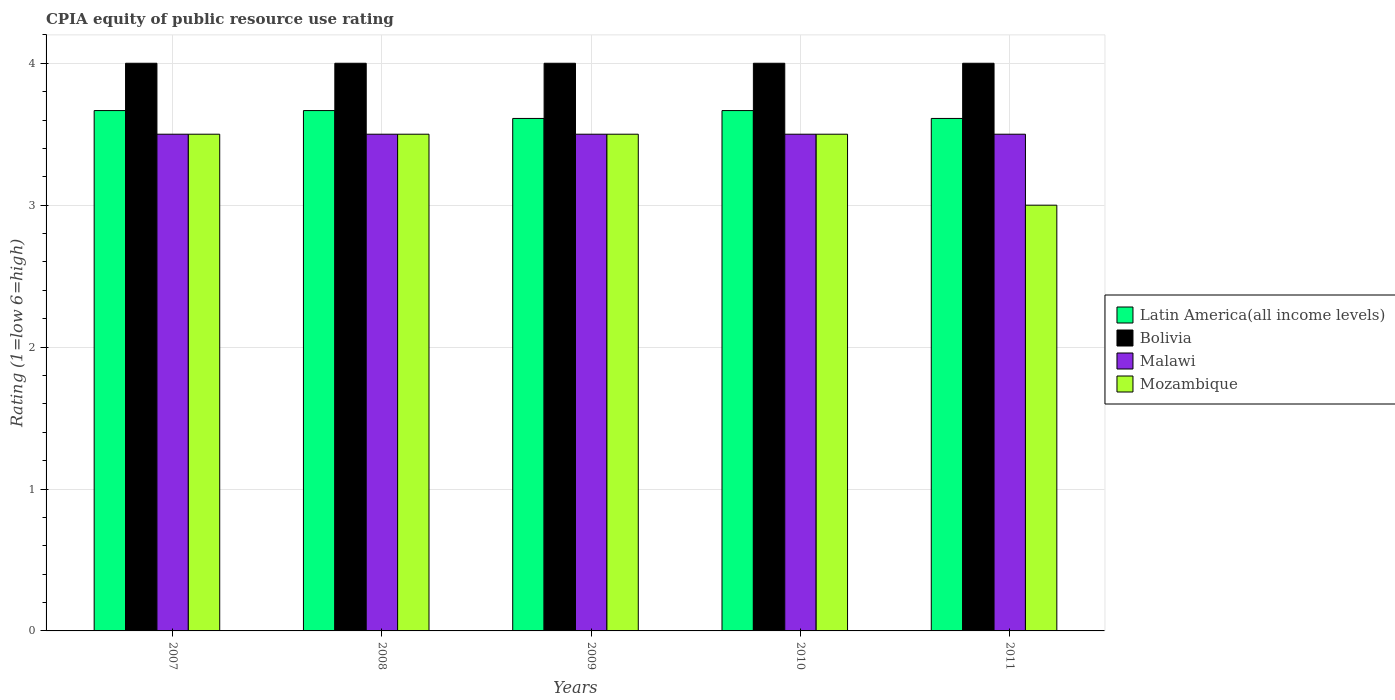How many different coloured bars are there?
Make the answer very short. 4. Are the number of bars on each tick of the X-axis equal?
Make the answer very short. Yes. How many bars are there on the 3rd tick from the right?
Ensure brevity in your answer.  4. What is the label of the 2nd group of bars from the left?
Offer a very short reply. 2008. In how many cases, is the number of bars for a given year not equal to the number of legend labels?
Ensure brevity in your answer.  0. What is the CPIA rating in Bolivia in 2009?
Give a very brief answer. 4. Across all years, what is the maximum CPIA rating in Malawi?
Provide a succinct answer. 3.5. Across all years, what is the minimum CPIA rating in Latin America(all income levels)?
Offer a terse response. 3.61. In which year was the CPIA rating in Mozambique minimum?
Your answer should be compact. 2011. What is the total CPIA rating in Malawi in the graph?
Make the answer very short. 17.5. What is the difference between the CPIA rating in Latin America(all income levels) in 2008 and that in 2011?
Your answer should be compact. 0.06. What is the difference between the CPIA rating in Latin America(all income levels) in 2011 and the CPIA rating in Bolivia in 2010?
Your answer should be very brief. -0.39. What is the average CPIA rating in Latin America(all income levels) per year?
Your answer should be very brief. 3.64. What is the ratio of the CPIA rating in Mozambique in 2009 to that in 2011?
Ensure brevity in your answer.  1.17. Is the CPIA rating in Bolivia in 2007 less than that in 2008?
Provide a short and direct response. No. What is the difference between the highest and the second highest CPIA rating in Bolivia?
Make the answer very short. 0. What is the difference between the highest and the lowest CPIA rating in Latin America(all income levels)?
Your answer should be very brief. 0.06. In how many years, is the CPIA rating in Bolivia greater than the average CPIA rating in Bolivia taken over all years?
Provide a succinct answer. 0. Is it the case that in every year, the sum of the CPIA rating in Malawi and CPIA rating in Bolivia is greater than the sum of CPIA rating in Latin America(all income levels) and CPIA rating in Mozambique?
Give a very brief answer. No. What does the 3rd bar from the left in 2010 represents?
Provide a succinct answer. Malawi. What does the 1st bar from the right in 2011 represents?
Offer a terse response. Mozambique. How many bars are there?
Provide a short and direct response. 20. Are all the bars in the graph horizontal?
Your answer should be very brief. No. Are the values on the major ticks of Y-axis written in scientific E-notation?
Provide a succinct answer. No. Where does the legend appear in the graph?
Ensure brevity in your answer.  Center right. How many legend labels are there?
Make the answer very short. 4. What is the title of the graph?
Your response must be concise. CPIA equity of public resource use rating. What is the Rating (1=low 6=high) of Latin America(all income levels) in 2007?
Offer a terse response. 3.67. What is the Rating (1=low 6=high) of Malawi in 2007?
Offer a terse response. 3.5. What is the Rating (1=low 6=high) of Mozambique in 2007?
Keep it short and to the point. 3.5. What is the Rating (1=low 6=high) in Latin America(all income levels) in 2008?
Make the answer very short. 3.67. What is the Rating (1=low 6=high) in Bolivia in 2008?
Offer a terse response. 4. What is the Rating (1=low 6=high) in Malawi in 2008?
Keep it short and to the point. 3.5. What is the Rating (1=low 6=high) of Mozambique in 2008?
Your answer should be very brief. 3.5. What is the Rating (1=low 6=high) of Latin America(all income levels) in 2009?
Make the answer very short. 3.61. What is the Rating (1=low 6=high) in Bolivia in 2009?
Your answer should be compact. 4. What is the Rating (1=low 6=high) of Mozambique in 2009?
Provide a short and direct response. 3.5. What is the Rating (1=low 6=high) in Latin America(all income levels) in 2010?
Provide a short and direct response. 3.67. What is the Rating (1=low 6=high) in Malawi in 2010?
Ensure brevity in your answer.  3.5. What is the Rating (1=low 6=high) in Mozambique in 2010?
Your answer should be very brief. 3.5. What is the Rating (1=low 6=high) in Latin America(all income levels) in 2011?
Provide a succinct answer. 3.61. Across all years, what is the maximum Rating (1=low 6=high) of Latin America(all income levels)?
Make the answer very short. 3.67. Across all years, what is the maximum Rating (1=low 6=high) in Bolivia?
Your response must be concise. 4. Across all years, what is the maximum Rating (1=low 6=high) of Malawi?
Your answer should be compact. 3.5. Across all years, what is the minimum Rating (1=low 6=high) of Latin America(all income levels)?
Your answer should be very brief. 3.61. Across all years, what is the minimum Rating (1=low 6=high) in Bolivia?
Provide a succinct answer. 4. Across all years, what is the minimum Rating (1=low 6=high) of Malawi?
Make the answer very short. 3.5. Across all years, what is the minimum Rating (1=low 6=high) in Mozambique?
Keep it short and to the point. 3. What is the total Rating (1=low 6=high) of Latin America(all income levels) in the graph?
Your response must be concise. 18.22. What is the total Rating (1=low 6=high) in Malawi in the graph?
Provide a succinct answer. 17.5. What is the total Rating (1=low 6=high) of Mozambique in the graph?
Ensure brevity in your answer.  17. What is the difference between the Rating (1=low 6=high) in Latin America(all income levels) in 2007 and that in 2008?
Offer a terse response. 0. What is the difference between the Rating (1=low 6=high) of Latin America(all income levels) in 2007 and that in 2009?
Your answer should be very brief. 0.06. What is the difference between the Rating (1=low 6=high) of Malawi in 2007 and that in 2009?
Provide a succinct answer. 0. What is the difference between the Rating (1=low 6=high) in Mozambique in 2007 and that in 2009?
Offer a terse response. 0. What is the difference between the Rating (1=low 6=high) of Bolivia in 2007 and that in 2010?
Provide a succinct answer. 0. What is the difference between the Rating (1=low 6=high) in Mozambique in 2007 and that in 2010?
Your answer should be compact. 0. What is the difference between the Rating (1=low 6=high) in Latin America(all income levels) in 2007 and that in 2011?
Ensure brevity in your answer.  0.06. What is the difference between the Rating (1=low 6=high) in Bolivia in 2007 and that in 2011?
Your response must be concise. 0. What is the difference between the Rating (1=low 6=high) in Mozambique in 2007 and that in 2011?
Your response must be concise. 0.5. What is the difference between the Rating (1=low 6=high) of Latin America(all income levels) in 2008 and that in 2009?
Provide a short and direct response. 0.06. What is the difference between the Rating (1=low 6=high) of Malawi in 2008 and that in 2009?
Ensure brevity in your answer.  0. What is the difference between the Rating (1=low 6=high) of Mozambique in 2008 and that in 2009?
Keep it short and to the point. 0. What is the difference between the Rating (1=low 6=high) in Latin America(all income levels) in 2008 and that in 2011?
Your response must be concise. 0.06. What is the difference between the Rating (1=low 6=high) in Bolivia in 2008 and that in 2011?
Provide a short and direct response. 0. What is the difference between the Rating (1=low 6=high) in Latin America(all income levels) in 2009 and that in 2010?
Provide a succinct answer. -0.06. What is the difference between the Rating (1=low 6=high) of Bolivia in 2009 and that in 2010?
Offer a terse response. 0. What is the difference between the Rating (1=low 6=high) in Malawi in 2009 and that in 2010?
Ensure brevity in your answer.  0. What is the difference between the Rating (1=low 6=high) of Mozambique in 2009 and that in 2010?
Keep it short and to the point. 0. What is the difference between the Rating (1=low 6=high) in Latin America(all income levels) in 2009 and that in 2011?
Offer a very short reply. 0. What is the difference between the Rating (1=low 6=high) of Bolivia in 2009 and that in 2011?
Give a very brief answer. 0. What is the difference between the Rating (1=low 6=high) of Malawi in 2009 and that in 2011?
Your answer should be very brief. 0. What is the difference between the Rating (1=low 6=high) in Latin America(all income levels) in 2010 and that in 2011?
Offer a terse response. 0.06. What is the difference between the Rating (1=low 6=high) in Mozambique in 2010 and that in 2011?
Your answer should be very brief. 0.5. What is the difference between the Rating (1=low 6=high) in Latin America(all income levels) in 2007 and the Rating (1=low 6=high) in Mozambique in 2008?
Provide a short and direct response. 0.17. What is the difference between the Rating (1=low 6=high) of Bolivia in 2007 and the Rating (1=low 6=high) of Mozambique in 2008?
Ensure brevity in your answer.  0.5. What is the difference between the Rating (1=low 6=high) of Malawi in 2007 and the Rating (1=low 6=high) of Mozambique in 2008?
Make the answer very short. 0. What is the difference between the Rating (1=low 6=high) of Latin America(all income levels) in 2007 and the Rating (1=low 6=high) of Bolivia in 2009?
Give a very brief answer. -0.33. What is the difference between the Rating (1=low 6=high) of Latin America(all income levels) in 2007 and the Rating (1=low 6=high) of Malawi in 2009?
Keep it short and to the point. 0.17. What is the difference between the Rating (1=low 6=high) in Latin America(all income levels) in 2007 and the Rating (1=low 6=high) in Mozambique in 2009?
Your response must be concise. 0.17. What is the difference between the Rating (1=low 6=high) in Bolivia in 2007 and the Rating (1=low 6=high) in Malawi in 2009?
Provide a succinct answer. 0.5. What is the difference between the Rating (1=low 6=high) of Malawi in 2007 and the Rating (1=low 6=high) of Mozambique in 2009?
Make the answer very short. 0. What is the difference between the Rating (1=low 6=high) of Latin America(all income levels) in 2007 and the Rating (1=low 6=high) of Bolivia in 2010?
Provide a succinct answer. -0.33. What is the difference between the Rating (1=low 6=high) of Bolivia in 2007 and the Rating (1=low 6=high) of Mozambique in 2010?
Your answer should be compact. 0.5. What is the difference between the Rating (1=low 6=high) in Malawi in 2007 and the Rating (1=low 6=high) in Mozambique in 2010?
Provide a succinct answer. 0. What is the difference between the Rating (1=low 6=high) of Latin America(all income levels) in 2007 and the Rating (1=low 6=high) of Malawi in 2011?
Provide a short and direct response. 0.17. What is the difference between the Rating (1=low 6=high) of Bolivia in 2007 and the Rating (1=low 6=high) of Malawi in 2011?
Offer a terse response. 0.5. What is the difference between the Rating (1=low 6=high) in Malawi in 2007 and the Rating (1=low 6=high) in Mozambique in 2011?
Provide a succinct answer. 0.5. What is the difference between the Rating (1=low 6=high) in Bolivia in 2008 and the Rating (1=low 6=high) in Malawi in 2009?
Offer a very short reply. 0.5. What is the difference between the Rating (1=low 6=high) of Bolivia in 2008 and the Rating (1=low 6=high) of Mozambique in 2009?
Keep it short and to the point. 0.5. What is the difference between the Rating (1=low 6=high) in Malawi in 2008 and the Rating (1=low 6=high) in Mozambique in 2009?
Provide a succinct answer. 0. What is the difference between the Rating (1=low 6=high) of Latin America(all income levels) in 2008 and the Rating (1=low 6=high) of Malawi in 2010?
Your answer should be very brief. 0.17. What is the difference between the Rating (1=low 6=high) of Latin America(all income levels) in 2008 and the Rating (1=low 6=high) of Mozambique in 2010?
Give a very brief answer. 0.17. What is the difference between the Rating (1=low 6=high) of Bolivia in 2008 and the Rating (1=low 6=high) of Mozambique in 2010?
Your response must be concise. 0.5. What is the difference between the Rating (1=low 6=high) of Malawi in 2008 and the Rating (1=low 6=high) of Mozambique in 2010?
Offer a terse response. 0. What is the difference between the Rating (1=low 6=high) of Latin America(all income levels) in 2008 and the Rating (1=low 6=high) of Bolivia in 2011?
Your answer should be very brief. -0.33. What is the difference between the Rating (1=low 6=high) in Latin America(all income levels) in 2008 and the Rating (1=low 6=high) in Malawi in 2011?
Your answer should be very brief. 0.17. What is the difference between the Rating (1=low 6=high) of Latin America(all income levels) in 2008 and the Rating (1=low 6=high) of Mozambique in 2011?
Make the answer very short. 0.67. What is the difference between the Rating (1=low 6=high) in Bolivia in 2008 and the Rating (1=low 6=high) in Malawi in 2011?
Your response must be concise. 0.5. What is the difference between the Rating (1=low 6=high) in Malawi in 2008 and the Rating (1=low 6=high) in Mozambique in 2011?
Your answer should be compact. 0.5. What is the difference between the Rating (1=low 6=high) of Latin America(all income levels) in 2009 and the Rating (1=low 6=high) of Bolivia in 2010?
Your response must be concise. -0.39. What is the difference between the Rating (1=low 6=high) of Latin America(all income levels) in 2009 and the Rating (1=low 6=high) of Malawi in 2010?
Give a very brief answer. 0.11. What is the difference between the Rating (1=low 6=high) in Bolivia in 2009 and the Rating (1=low 6=high) in Malawi in 2010?
Provide a short and direct response. 0.5. What is the difference between the Rating (1=low 6=high) of Malawi in 2009 and the Rating (1=low 6=high) of Mozambique in 2010?
Offer a terse response. 0. What is the difference between the Rating (1=low 6=high) in Latin America(all income levels) in 2009 and the Rating (1=low 6=high) in Bolivia in 2011?
Ensure brevity in your answer.  -0.39. What is the difference between the Rating (1=low 6=high) of Latin America(all income levels) in 2009 and the Rating (1=low 6=high) of Mozambique in 2011?
Your answer should be compact. 0.61. What is the difference between the Rating (1=low 6=high) of Bolivia in 2009 and the Rating (1=low 6=high) of Malawi in 2011?
Your answer should be very brief. 0.5. What is the difference between the Rating (1=low 6=high) of Bolivia in 2009 and the Rating (1=low 6=high) of Mozambique in 2011?
Your answer should be compact. 1. What is the difference between the Rating (1=low 6=high) in Malawi in 2009 and the Rating (1=low 6=high) in Mozambique in 2011?
Give a very brief answer. 0.5. What is the difference between the Rating (1=low 6=high) of Latin America(all income levels) in 2010 and the Rating (1=low 6=high) of Bolivia in 2011?
Offer a terse response. -0.33. What is the difference between the Rating (1=low 6=high) in Latin America(all income levels) in 2010 and the Rating (1=low 6=high) in Malawi in 2011?
Offer a terse response. 0.17. What is the difference between the Rating (1=low 6=high) of Latin America(all income levels) in 2010 and the Rating (1=low 6=high) of Mozambique in 2011?
Make the answer very short. 0.67. What is the difference between the Rating (1=low 6=high) of Bolivia in 2010 and the Rating (1=low 6=high) of Mozambique in 2011?
Provide a short and direct response. 1. What is the difference between the Rating (1=low 6=high) in Malawi in 2010 and the Rating (1=low 6=high) in Mozambique in 2011?
Keep it short and to the point. 0.5. What is the average Rating (1=low 6=high) in Latin America(all income levels) per year?
Offer a terse response. 3.64. What is the average Rating (1=low 6=high) in Bolivia per year?
Ensure brevity in your answer.  4. In the year 2007, what is the difference between the Rating (1=low 6=high) of Latin America(all income levels) and Rating (1=low 6=high) of Malawi?
Provide a short and direct response. 0.17. In the year 2007, what is the difference between the Rating (1=low 6=high) in Latin America(all income levels) and Rating (1=low 6=high) in Mozambique?
Your answer should be very brief. 0.17. In the year 2007, what is the difference between the Rating (1=low 6=high) of Bolivia and Rating (1=low 6=high) of Mozambique?
Offer a very short reply. 0.5. In the year 2007, what is the difference between the Rating (1=low 6=high) in Malawi and Rating (1=low 6=high) in Mozambique?
Provide a short and direct response. 0. In the year 2008, what is the difference between the Rating (1=low 6=high) of Latin America(all income levels) and Rating (1=low 6=high) of Bolivia?
Offer a very short reply. -0.33. In the year 2008, what is the difference between the Rating (1=low 6=high) in Latin America(all income levels) and Rating (1=low 6=high) in Mozambique?
Provide a short and direct response. 0.17. In the year 2008, what is the difference between the Rating (1=low 6=high) of Bolivia and Rating (1=low 6=high) of Malawi?
Your answer should be compact. 0.5. In the year 2009, what is the difference between the Rating (1=low 6=high) of Latin America(all income levels) and Rating (1=low 6=high) of Bolivia?
Your answer should be very brief. -0.39. In the year 2009, what is the difference between the Rating (1=low 6=high) of Latin America(all income levels) and Rating (1=low 6=high) of Malawi?
Provide a short and direct response. 0.11. In the year 2009, what is the difference between the Rating (1=low 6=high) of Latin America(all income levels) and Rating (1=low 6=high) of Mozambique?
Make the answer very short. 0.11. In the year 2009, what is the difference between the Rating (1=low 6=high) in Bolivia and Rating (1=low 6=high) in Malawi?
Your answer should be compact. 0.5. In the year 2009, what is the difference between the Rating (1=low 6=high) in Bolivia and Rating (1=low 6=high) in Mozambique?
Provide a short and direct response. 0.5. In the year 2010, what is the difference between the Rating (1=low 6=high) of Bolivia and Rating (1=low 6=high) of Malawi?
Ensure brevity in your answer.  0.5. In the year 2010, what is the difference between the Rating (1=low 6=high) in Malawi and Rating (1=low 6=high) in Mozambique?
Your response must be concise. 0. In the year 2011, what is the difference between the Rating (1=low 6=high) in Latin America(all income levels) and Rating (1=low 6=high) in Bolivia?
Provide a short and direct response. -0.39. In the year 2011, what is the difference between the Rating (1=low 6=high) of Latin America(all income levels) and Rating (1=low 6=high) of Mozambique?
Offer a very short reply. 0.61. In the year 2011, what is the difference between the Rating (1=low 6=high) of Malawi and Rating (1=low 6=high) of Mozambique?
Your response must be concise. 0.5. What is the ratio of the Rating (1=low 6=high) of Malawi in 2007 to that in 2008?
Give a very brief answer. 1. What is the ratio of the Rating (1=low 6=high) of Mozambique in 2007 to that in 2008?
Offer a very short reply. 1. What is the ratio of the Rating (1=low 6=high) of Latin America(all income levels) in 2007 to that in 2009?
Provide a succinct answer. 1.02. What is the ratio of the Rating (1=low 6=high) in Bolivia in 2007 to that in 2009?
Your response must be concise. 1. What is the ratio of the Rating (1=low 6=high) in Malawi in 2007 to that in 2009?
Ensure brevity in your answer.  1. What is the ratio of the Rating (1=low 6=high) in Latin America(all income levels) in 2007 to that in 2011?
Keep it short and to the point. 1.02. What is the ratio of the Rating (1=low 6=high) in Bolivia in 2007 to that in 2011?
Your answer should be compact. 1. What is the ratio of the Rating (1=low 6=high) in Malawi in 2007 to that in 2011?
Keep it short and to the point. 1. What is the ratio of the Rating (1=low 6=high) of Latin America(all income levels) in 2008 to that in 2009?
Your response must be concise. 1.02. What is the ratio of the Rating (1=low 6=high) of Bolivia in 2008 to that in 2009?
Provide a short and direct response. 1. What is the ratio of the Rating (1=low 6=high) of Mozambique in 2008 to that in 2009?
Your answer should be compact. 1. What is the ratio of the Rating (1=low 6=high) of Malawi in 2008 to that in 2010?
Make the answer very short. 1. What is the ratio of the Rating (1=low 6=high) in Latin America(all income levels) in 2008 to that in 2011?
Offer a very short reply. 1.02. What is the ratio of the Rating (1=low 6=high) of Bolivia in 2008 to that in 2011?
Provide a succinct answer. 1. What is the ratio of the Rating (1=low 6=high) in Malawi in 2008 to that in 2011?
Your answer should be compact. 1. What is the ratio of the Rating (1=low 6=high) in Mozambique in 2008 to that in 2011?
Give a very brief answer. 1.17. What is the ratio of the Rating (1=low 6=high) of Malawi in 2009 to that in 2010?
Your answer should be very brief. 1. What is the ratio of the Rating (1=low 6=high) in Mozambique in 2009 to that in 2010?
Keep it short and to the point. 1. What is the ratio of the Rating (1=low 6=high) in Latin America(all income levels) in 2009 to that in 2011?
Offer a very short reply. 1. What is the ratio of the Rating (1=low 6=high) of Bolivia in 2009 to that in 2011?
Your answer should be very brief. 1. What is the ratio of the Rating (1=low 6=high) in Latin America(all income levels) in 2010 to that in 2011?
Offer a terse response. 1.02. What is the ratio of the Rating (1=low 6=high) in Malawi in 2010 to that in 2011?
Provide a short and direct response. 1. What is the ratio of the Rating (1=low 6=high) of Mozambique in 2010 to that in 2011?
Provide a short and direct response. 1.17. What is the difference between the highest and the second highest Rating (1=low 6=high) in Malawi?
Keep it short and to the point. 0. What is the difference between the highest and the second highest Rating (1=low 6=high) in Mozambique?
Make the answer very short. 0. What is the difference between the highest and the lowest Rating (1=low 6=high) in Latin America(all income levels)?
Ensure brevity in your answer.  0.06. What is the difference between the highest and the lowest Rating (1=low 6=high) of Bolivia?
Provide a short and direct response. 0. What is the difference between the highest and the lowest Rating (1=low 6=high) in Malawi?
Your answer should be very brief. 0. 